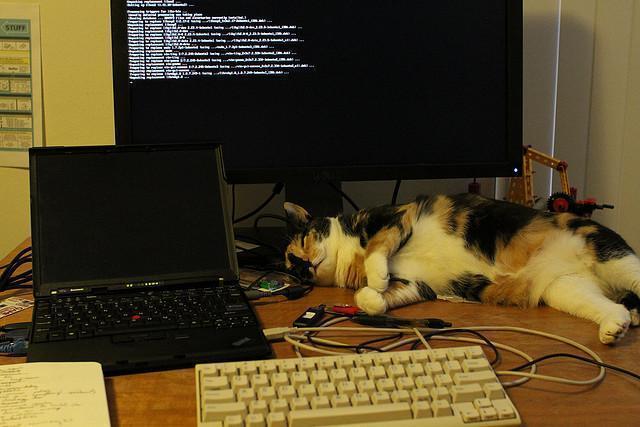What is the cat sleeping near?
Answer the question by selecting the correct answer among the 4 following choices and explain your choice with a short sentence. The answer should be formatted with the following format: `Answer: choice
Rationale: rationale.`
Options: Woman, baby, dog, computer. Answer: computer.
Rationale: The cat is by a computer. How many computer screens are around the cat sleeping on the desk?
Choose the correct response, then elucidate: 'Answer: answer
Rationale: rationale.'
Options: Two, three, five, four. Answer: two.
Rationale: There are 2. 